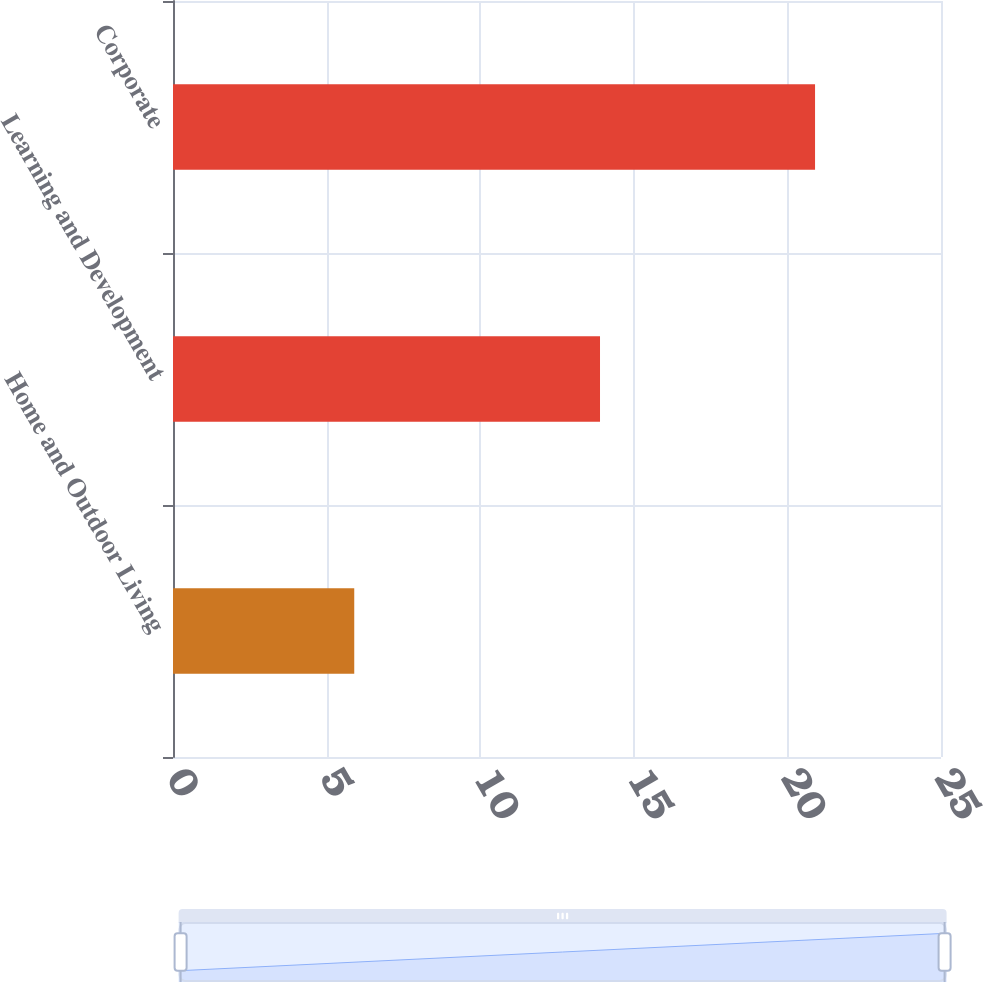<chart> <loc_0><loc_0><loc_500><loc_500><bar_chart><fcel>Home and Outdoor Living<fcel>Learning and Development<fcel>Corporate<nl><fcel>5.9<fcel>13.9<fcel>20.9<nl></chart> 